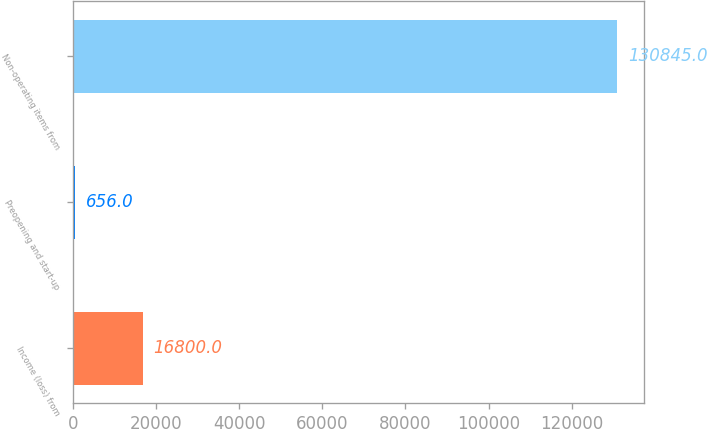Convert chart to OTSL. <chart><loc_0><loc_0><loc_500><loc_500><bar_chart><fcel>Income (loss) from<fcel>Preopening and start-up<fcel>Non-operating items from<nl><fcel>16800<fcel>656<fcel>130845<nl></chart> 